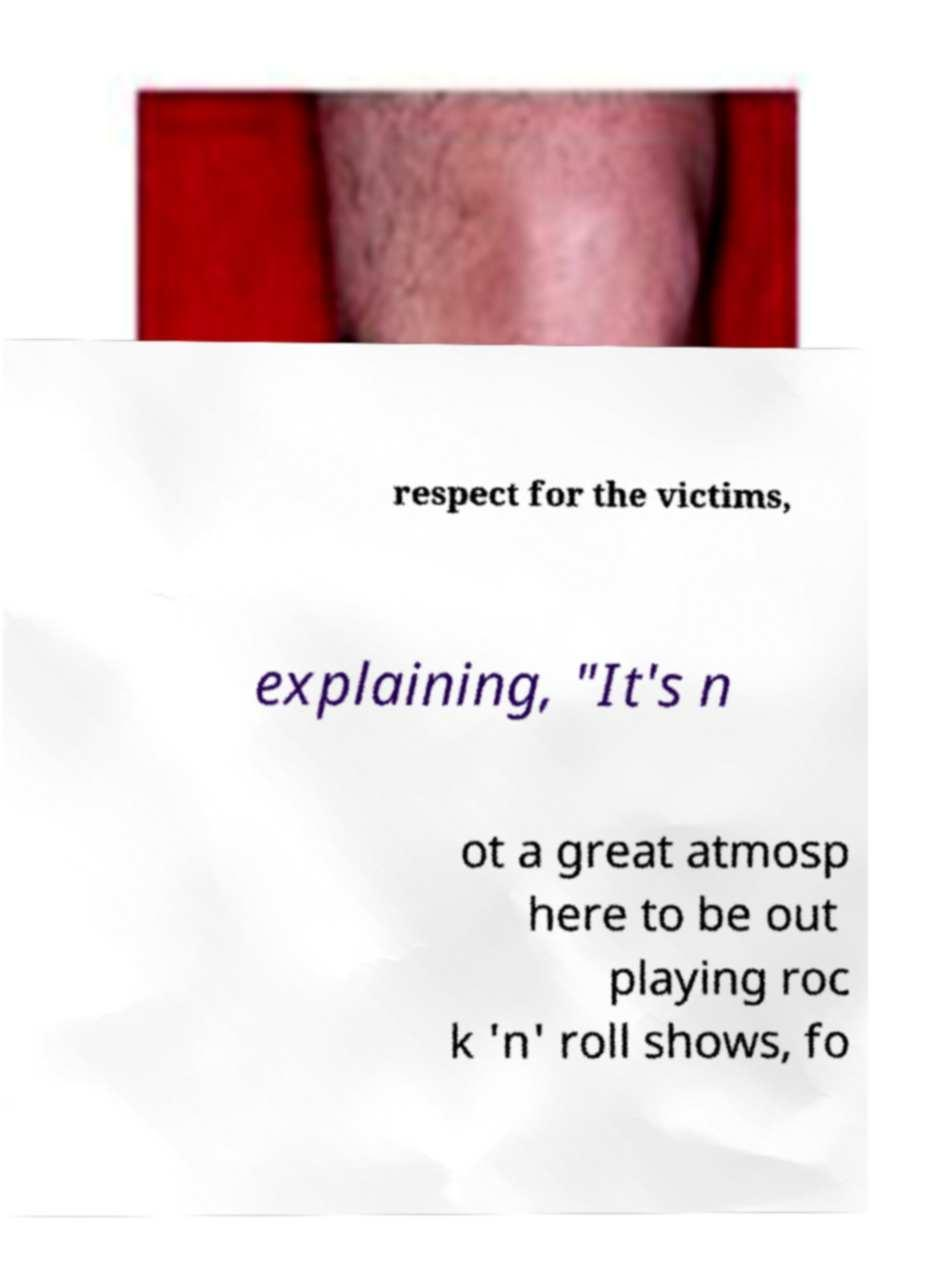Could you extract and type out the text from this image? respect for the victims, explaining, "It's n ot a great atmosp here to be out playing roc k 'n' roll shows, fo 